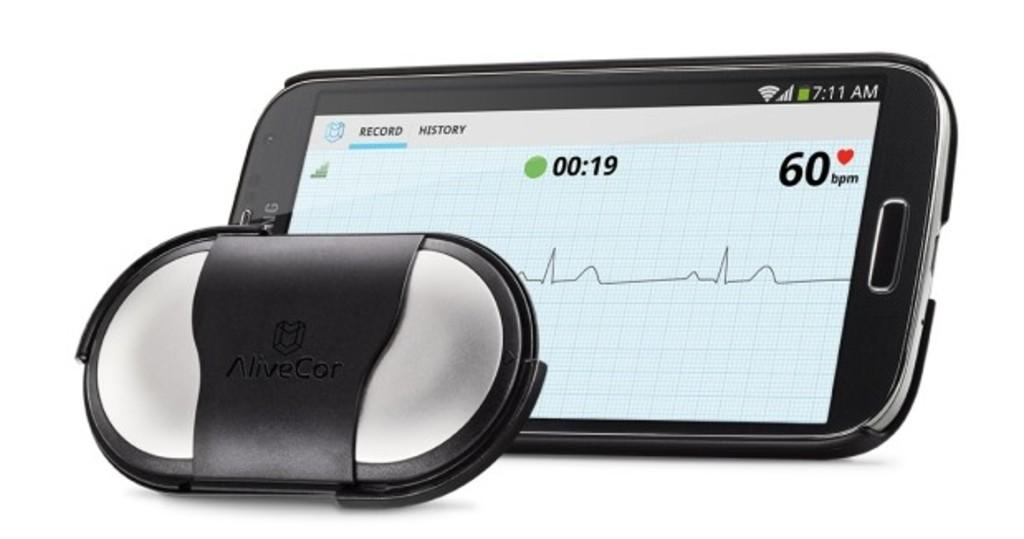Provide a one-sentence caption for the provided image. The alivecor device displays a record of Bpm. 